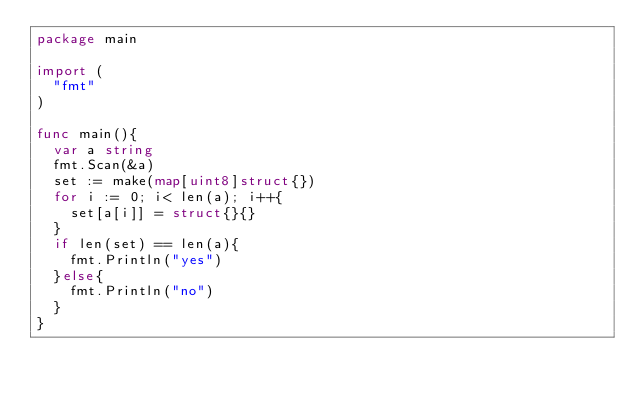<code> <loc_0><loc_0><loc_500><loc_500><_Go_>package main

import (
	"fmt"
)

func main(){
	var a string
	fmt.Scan(&a)
	set := make(map[uint8]struct{})
	for i := 0; i< len(a); i++{
		set[a[i]] = struct{}{}
	}
	if len(set) == len(a){
		fmt.Println("yes")
	}else{
		fmt.Println("no")
	}
}</code> 